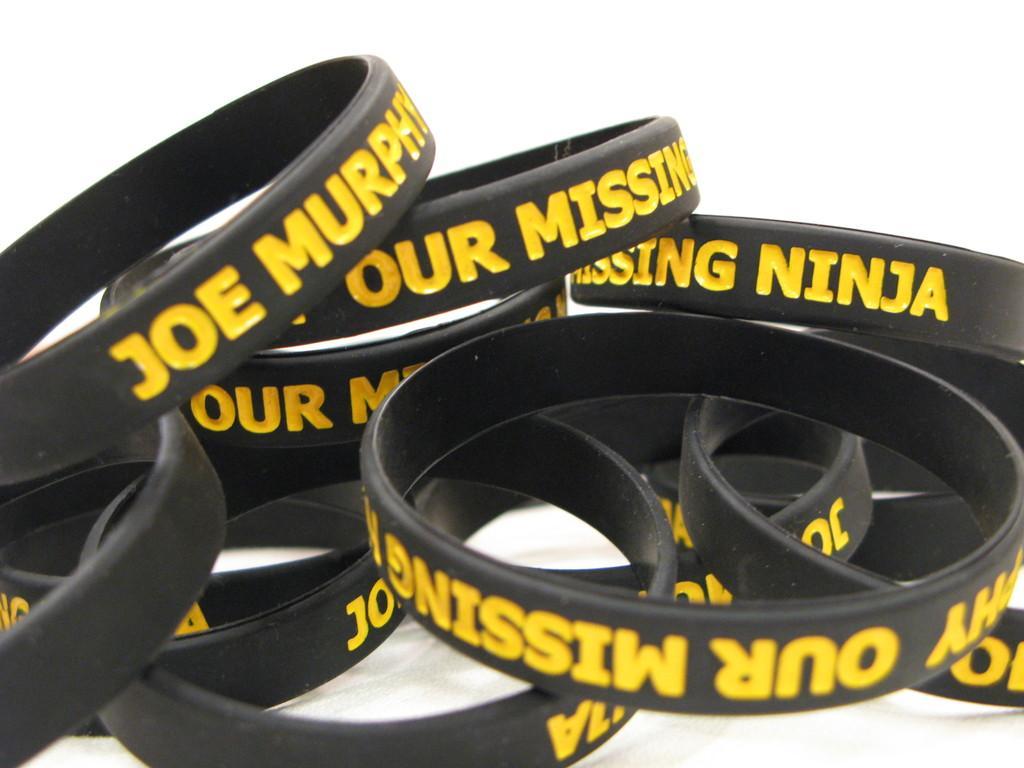What color is the text on the bands in the image? The text on the bands in the image is yellow. What is the color of the background in the image? The background of the image is white. Can you see a fire hydrant in the image? There is no fire hydrant present in the image. How many people are joining the bands in the image? The image does not show any people joining the bands, so it cannot be determined from the image. 